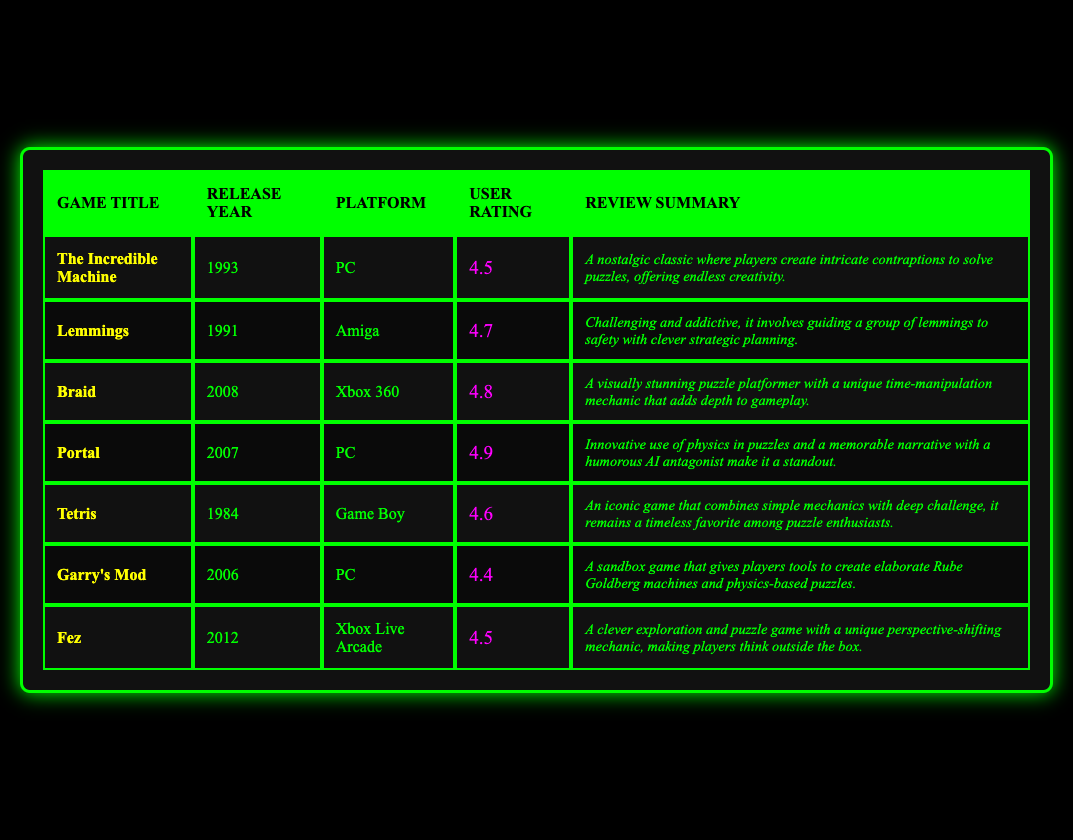What is the user rating for Portal? The rating can be found in the table under the "User Rating" column for the game "Portal". It shows a value of 4.9.
Answer: 4.9 Which game has the highest user rating? To determine the highest rating, I look through the "User Rating" column and find that "Portal" has the highest rating of 4.9.
Answer: Portal How many games were released after the year 2000? I can count the release years listed in the table. The games released after 2000 are "Braid" (2008), "Portal" (2007), "Garry's Mod" (2006), and "Fez" (2012). This gives a total of 4 games.
Answer: 4 Which game has a review summary mentioning Rube Goldberg machines? Referring to the "Review Summary" column, I find that "Garry's Mod" mentions the ability to create elaborate Rube Goldberg machines.
Answer: Garry's Mod What is the average user rating of all the listed games? First, I sum the user ratings: (4.5 + 4.7 + 4.8 + 4.9 + 4.6 + 4.4 + 4.5). This equals 33.4. There are 7 games, so I divide 33.4 by 7, which gives an average of approximately 4.77.
Answer: 4.77 Is Tetris rated higher than Garry's Mod? I can compare their ratings from the "User Rating" column. Tetris has a rating of 4.6, while Garry's Mod has a rating of 4.4, so Tetris is rated higher than Garry's Mod.
Answer: Yes Which two games have user ratings that are closest together? I inspect the user ratings and notice that "Garry's Mod" (4.4) and "Fez" (4.5) have the smallest difference of 0.1, indicating they are the closest in ratings.
Answer: Garry's Mod and Fez What is the percentage of games that are rated above 4.5? I first identify which games are rated above 4.5: "Lemmings" (4.7), "Braid" (4.8), "Portal" (4.9), and "Tetris" (4.6), totaling 4 games. There are 7 games in total, so the percentage is (4/7) * 100 = approximately 57.14%.
Answer: 57.14% 